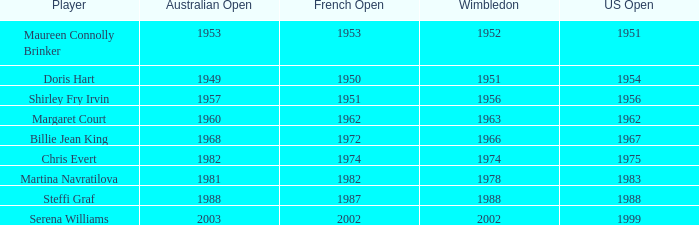When did Shirley Fry Irvin win the US Open? 1956.0. 